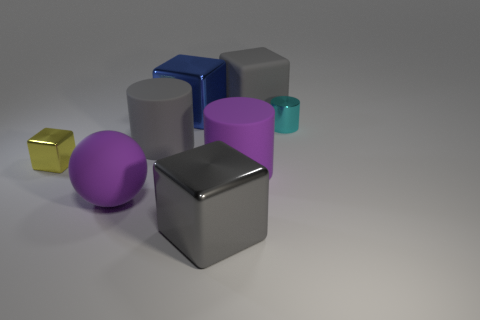Are the tiny thing that is to the right of the large gray matte block and the big gray block that is in front of the blue metal cube made of the same material?
Your answer should be very brief. Yes. The small cyan metal object has what shape?
Provide a succinct answer. Cylinder. Are there more gray rubber cylinders that are in front of the small metal block than large blue cubes that are behind the tiny cyan shiny cylinder?
Give a very brief answer. No. Does the large gray rubber thing that is behind the big blue metallic cube have the same shape as the purple object to the right of the large sphere?
Offer a terse response. No. What number of other things are the same size as the gray matte cylinder?
Offer a terse response. 5. What size is the cyan cylinder?
Provide a short and direct response. Small. Is the small thing that is on the left side of the cyan metallic cylinder made of the same material as the blue object?
Make the answer very short. Yes. The other big rubber thing that is the same shape as the blue thing is what color?
Offer a terse response. Gray. There is a large shiny thing that is behind the yellow metal cube; is it the same color as the rubber block?
Provide a short and direct response. No. There is a small cyan thing; are there any gray matte cylinders in front of it?
Ensure brevity in your answer.  Yes. 